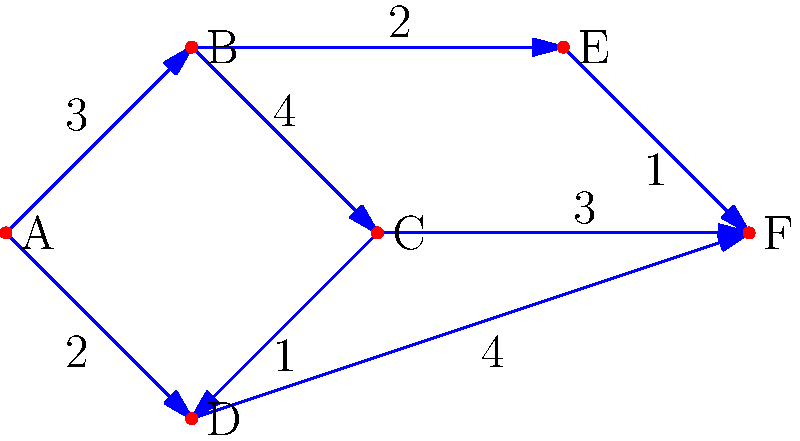In our recent collaboration on graph theory, we encountered a weighted graph representing the connections between various research institutions. Given the graph above, what is the shortest path from node A to node F, and what is its total weight? Let's approach this step-by-step using Dijkstra's algorithm, which we often used in our joint research:

1) Initialize:
   - Distance to A = 0
   - Distance to all other nodes = infinity
   - Set of visited nodes = empty

2) Start from node A:
   - Update distances: B(3), D(2)
   - Mark A as visited

3) Choose the node with the smallest distance (D):
   - Update distances: C(2+1=3)
   - Mark D as visited

4) Choose the node with the smallest distance (B or C, both 3):
   Let's choose B:
   - Update distances: E(3+2=5)
   - Mark B as visited

5) Choose C (distance 3):
   - Update distances: F(3+3=6)
   - Mark C as visited

6) Choose E (distance 5):
   - Update distances: F(5+1=6)
   - Mark E as visited

7) Choose F (distance 6):
   - No updates needed
   - Mark F as visited

The shortest path is therefore A → D → C → F, with a total weight of 2 + 1 + 3 = 6.
Answer: A → D → C → F, weight 6 